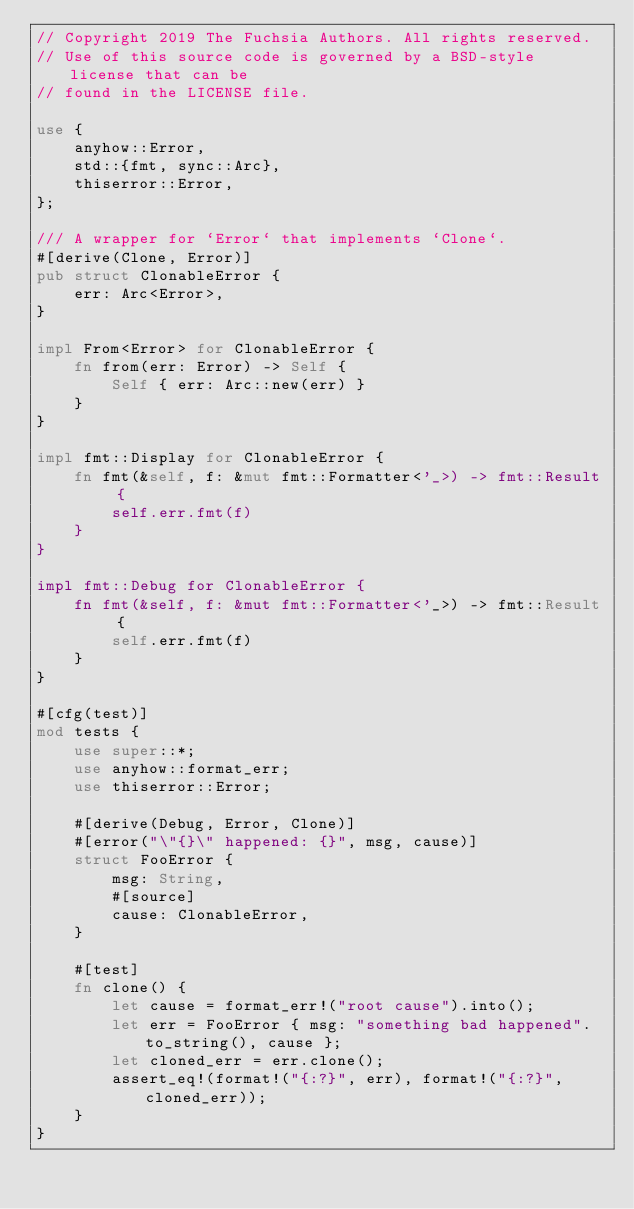Convert code to text. <code><loc_0><loc_0><loc_500><loc_500><_Rust_>// Copyright 2019 The Fuchsia Authors. All rights reserved.
// Use of this source code is governed by a BSD-style license that can be
// found in the LICENSE file.

use {
    anyhow::Error,
    std::{fmt, sync::Arc},
    thiserror::Error,
};

/// A wrapper for `Error` that implements `Clone`.
#[derive(Clone, Error)]
pub struct ClonableError {
    err: Arc<Error>,
}

impl From<Error> for ClonableError {
    fn from(err: Error) -> Self {
        Self { err: Arc::new(err) }
    }
}

impl fmt::Display for ClonableError {
    fn fmt(&self, f: &mut fmt::Formatter<'_>) -> fmt::Result {
        self.err.fmt(f)
    }
}

impl fmt::Debug for ClonableError {
    fn fmt(&self, f: &mut fmt::Formatter<'_>) -> fmt::Result {
        self.err.fmt(f)
    }
}

#[cfg(test)]
mod tests {
    use super::*;
    use anyhow::format_err;
    use thiserror::Error;

    #[derive(Debug, Error, Clone)]
    #[error("\"{}\" happened: {}", msg, cause)]
    struct FooError {
        msg: String,
        #[source]
        cause: ClonableError,
    }

    #[test]
    fn clone() {
        let cause = format_err!("root cause").into();
        let err = FooError { msg: "something bad happened".to_string(), cause };
        let cloned_err = err.clone();
        assert_eq!(format!("{:?}", err), format!("{:?}", cloned_err));
    }
}
</code> 